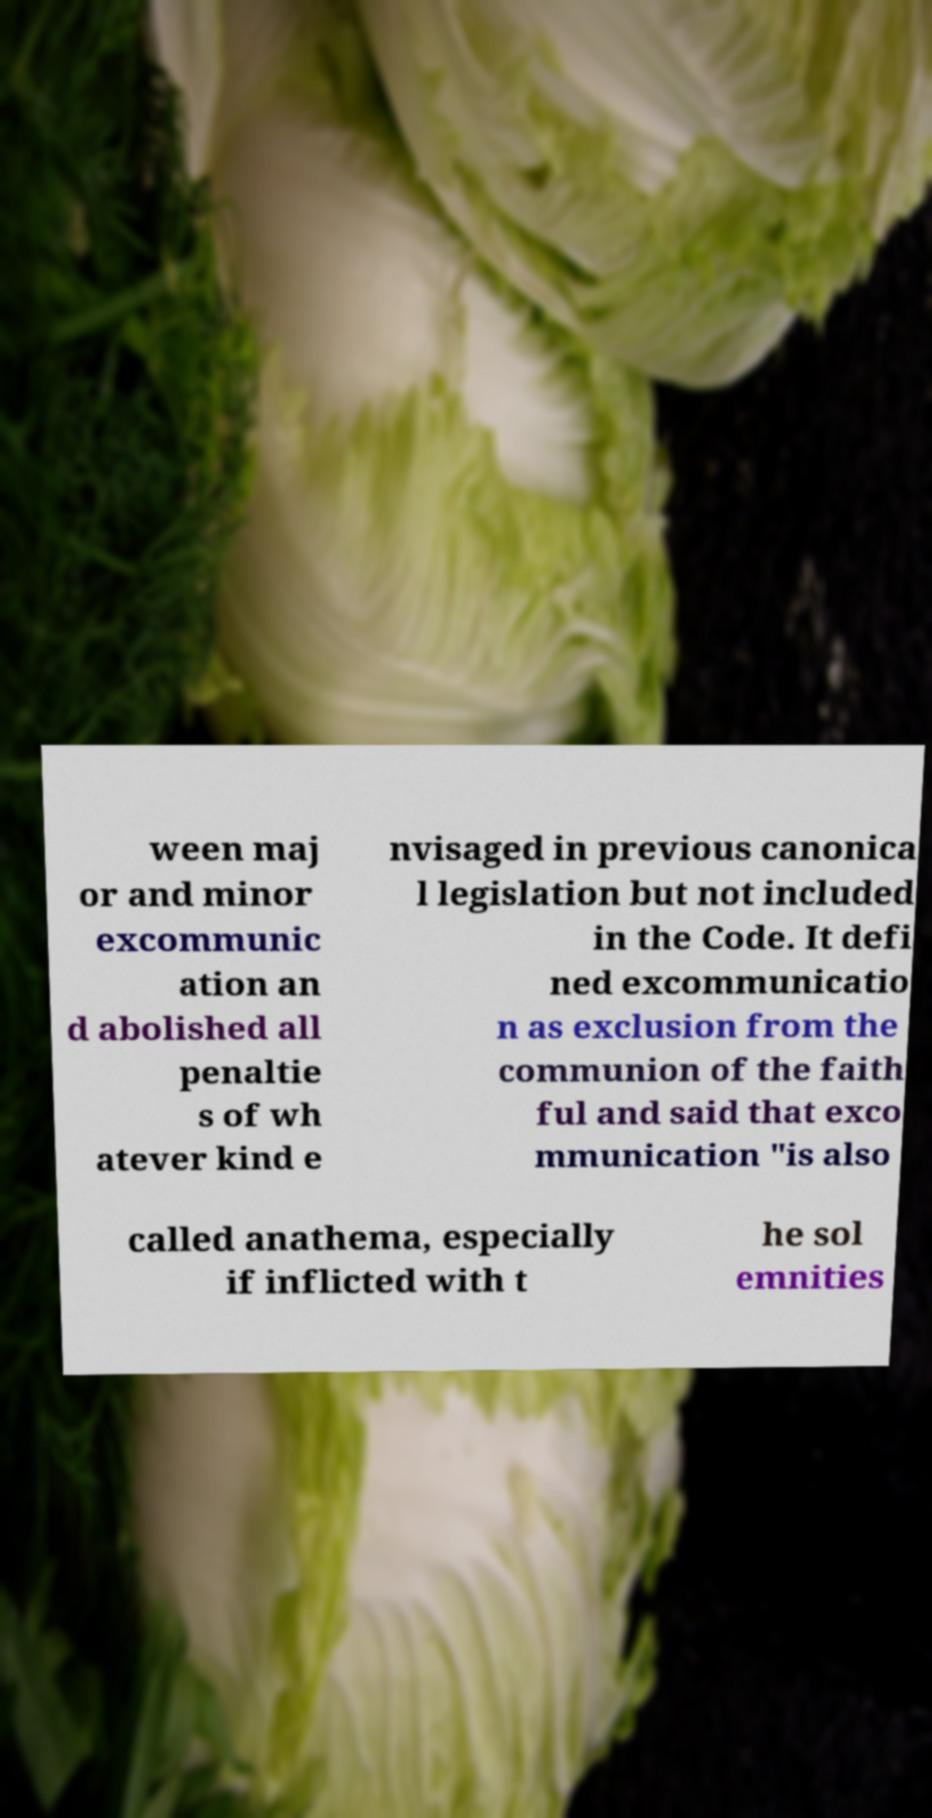Can you read and provide the text displayed in the image?This photo seems to have some interesting text. Can you extract and type it out for me? ween maj or and minor excommunic ation an d abolished all penaltie s of wh atever kind e nvisaged in previous canonica l legislation but not included in the Code. It defi ned excommunicatio n as exclusion from the communion of the faith ful and said that exco mmunication "is also called anathema, especially if inflicted with t he sol emnities 